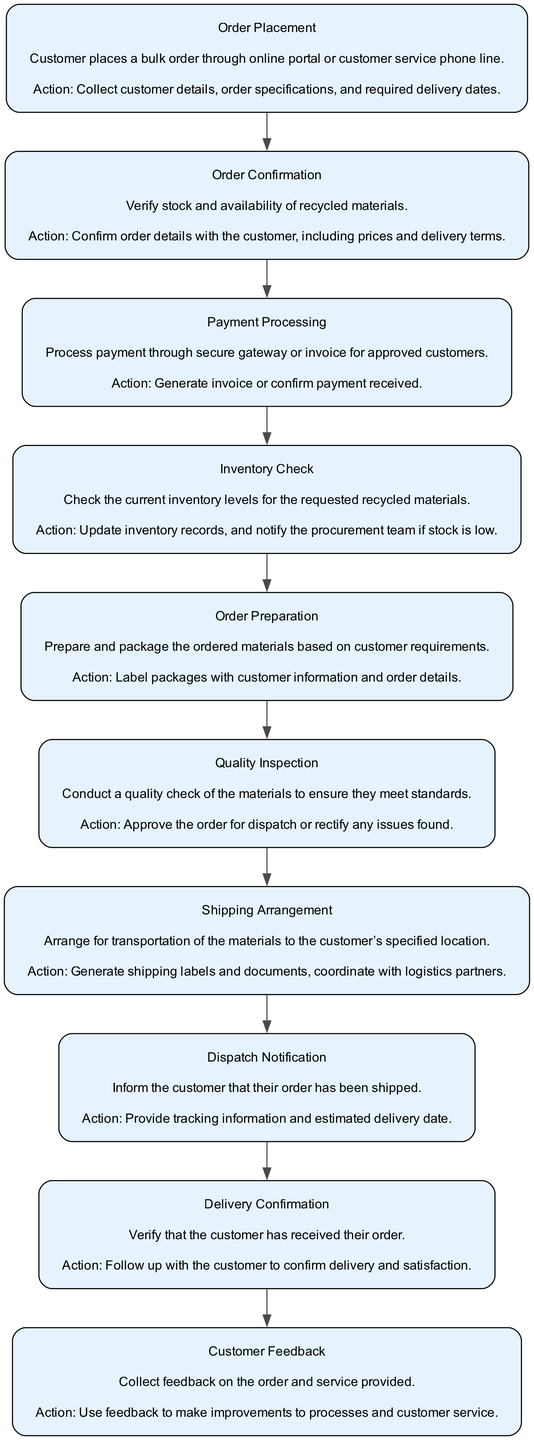What is the first step in the flow chart? The first step in the flow chart is "Order Placement," where the customer places a bulk order.
Answer: Order Placement How many nodes are there in the diagram? By counting the distinct elements within the diagram, we find there are ten nodes, each representing a step in the process.
Answer: Ten Which process comes after "Payment Processing"? Following "Payment Processing," the next step is "Inventory Check," which indicates the sequence of actions as the order is being processed.
Answer: Inventory Check What action is taken during "Quality Inspection"? During "Quality Inspection," the action taken is to conduct a quality check of the materials to ensure they meet standards.
Answer: Conduct a quality check What happens if the stock is low during "Inventory Check"? If stock is low during "Inventory Check," the system notifies the procurement team to address the inventory issue.
Answer: Notify the procurement team How is the customer informed after the order is shipped? After the order is shipped, the customer is informed through "Dispatch Notification," which includes tracking information and estimated delivery date.
Answer: Dispatch Notification Is "Customer Feedback" the final step in the process? Yes, "Customer Feedback" is the final step and involves collecting feedback on the order and service provided, indicating the completion of the service process.
Answer: Yes Which step includes confirming payment received? The step that includes confirming payment received is "Payment Processing," which deals with processing payments through a secure gateway or invoicing for approved customers.
Answer: Payment Processing What is the primary action during "Order Preparation"? The primary action during "Order Preparation" is to prepare and package the ordered materials based on customer requirements.
Answer: Prepare and package the ordered materials 